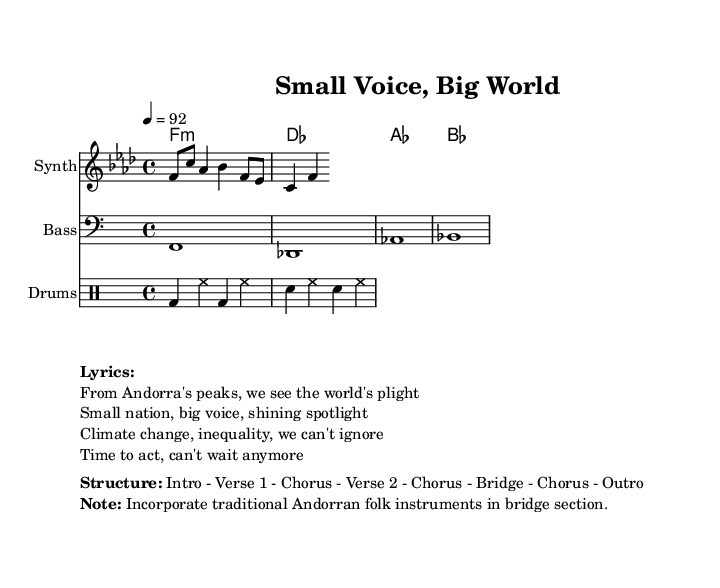What is the key signature of this music? The key signature is indicated by the 'key' command in the code, specified as 'f minor', which typically has four flats (B♭, E♭, A♭, D♭).
Answer: f minor What is the time signature of this piece? The time signature is specified in the code as '4/4', which indicates that there are four beats in each measure and a quarter note receives one beat.
Answer: 4/4 What is the tempo marking for this score? The tempo marking is specified in the 'tempo' command within the code, set at a quarter note value of 92 beats per minute, indicating the speed of the music.
Answer: 92 How many verses are in the song structure? The structure includes 'Verse 1' and 'Verse 2', as listed, indicating that there are two distinct verses in the song.
Answer: 2 What type of rhythmic pattern is used for the drums? The drum pattern is represented in the code using 'bd' for bass drum, 'sn' for snare drum, and 'hh' for hi-hat, showing a basic groove characteristic of hip-hop rhythm.
Answer: Basic groove Which section of the song incorporates traditional Andorran folk instruments? The note section of the markup specifies that traditional Andorran folk instruments are to be incorporated in the 'bridge' section.
Answer: Bridge What overarching theme does the lyrics exemplify? The lyrics highlight a 'political awareness and activism' while addressing global issues as seen in the lines discussing climate change and inequality.
Answer: Political awareness 